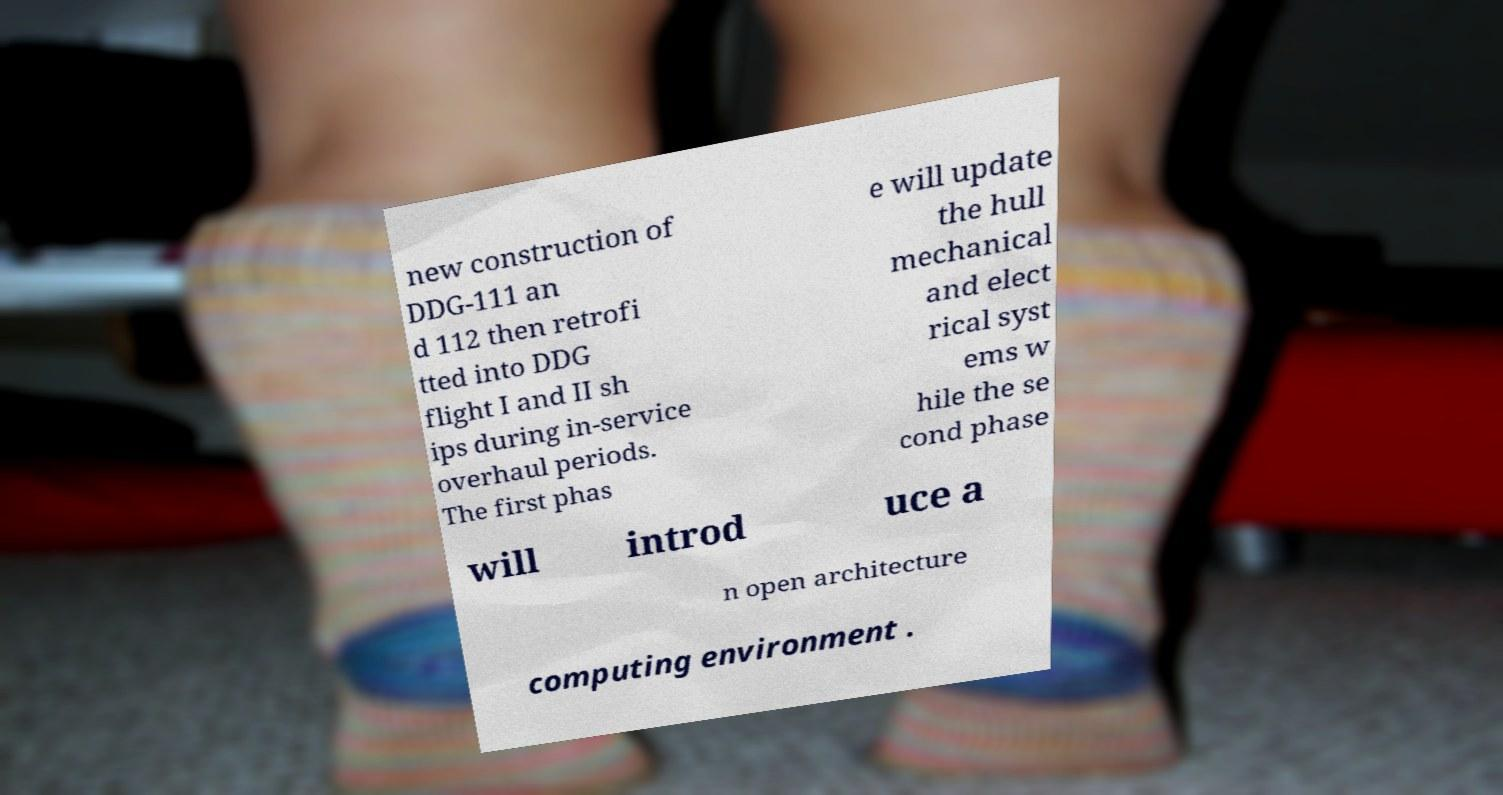Can you read and provide the text displayed in the image?This photo seems to have some interesting text. Can you extract and type it out for me? new construction of DDG-111 an d 112 then retrofi tted into DDG flight I and II sh ips during in-service overhaul periods. The first phas e will update the hull mechanical and elect rical syst ems w hile the se cond phase will introd uce a n open architecture computing environment . 